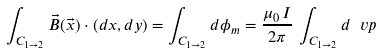Convert formula to latex. <formula><loc_0><loc_0><loc_500><loc_500>\int _ { C _ { 1 \to 2 } } \vec { B } ( \vec { x } ) \cdot ( d x , d y ) = \int _ { C _ { 1 \to 2 } } d \phi _ { m } = \frac { \mu _ { 0 } \, I } { 2 \pi } \, \int _ { C _ { 1 \to 2 } } d \ v p</formula> 